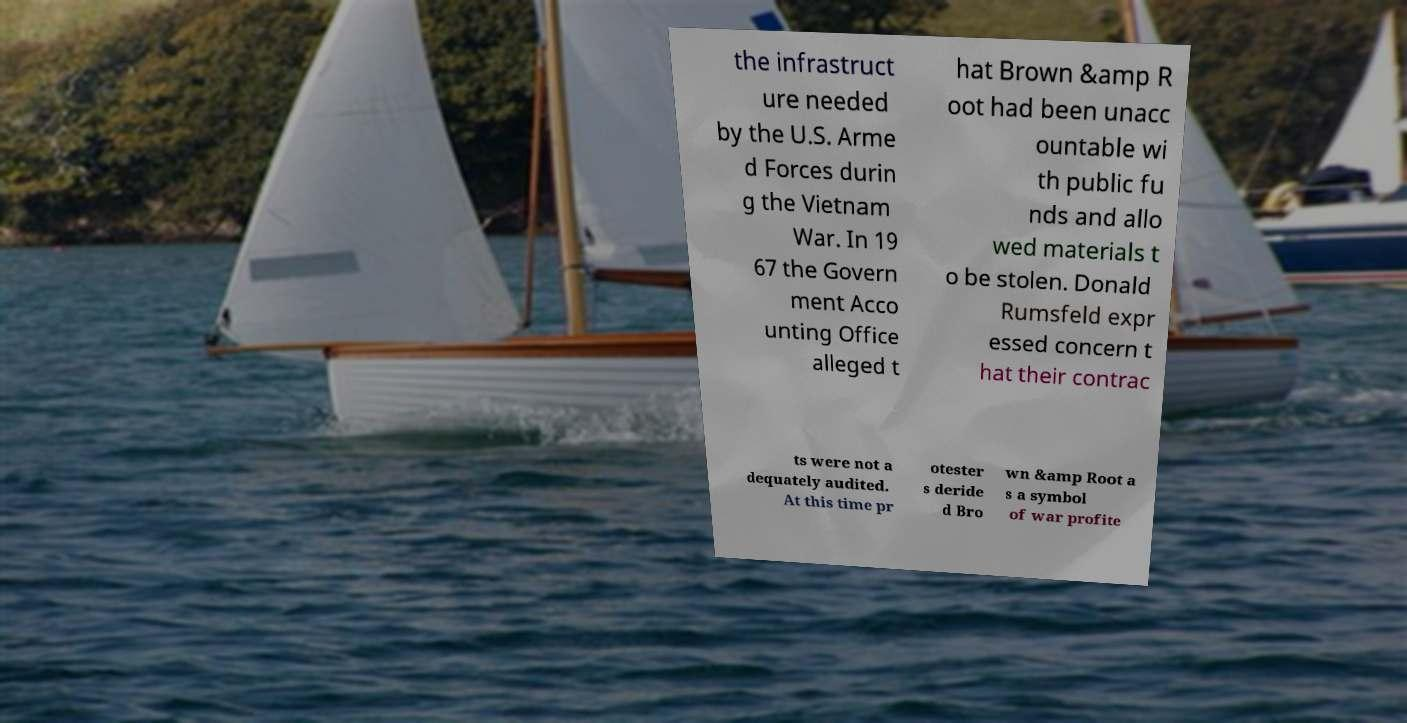Please identify and transcribe the text found in this image. the infrastruct ure needed by the U.S. Arme d Forces durin g the Vietnam War. In 19 67 the Govern ment Acco unting Office alleged t hat Brown &amp R oot had been unacc ountable wi th public fu nds and allo wed materials t o be stolen. Donald Rumsfeld expr essed concern t hat their contrac ts were not a dequately audited. At this time pr otester s deride d Bro wn &amp Root a s a symbol of war profite 